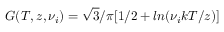Convert formula to latex. <formula><loc_0><loc_0><loc_500><loc_500>G ( T , z , \nu _ { i } ) = \sqrt { 3 } / \pi [ 1 / 2 + \ln ( \nu _ { i } k T / z ) ]</formula> 